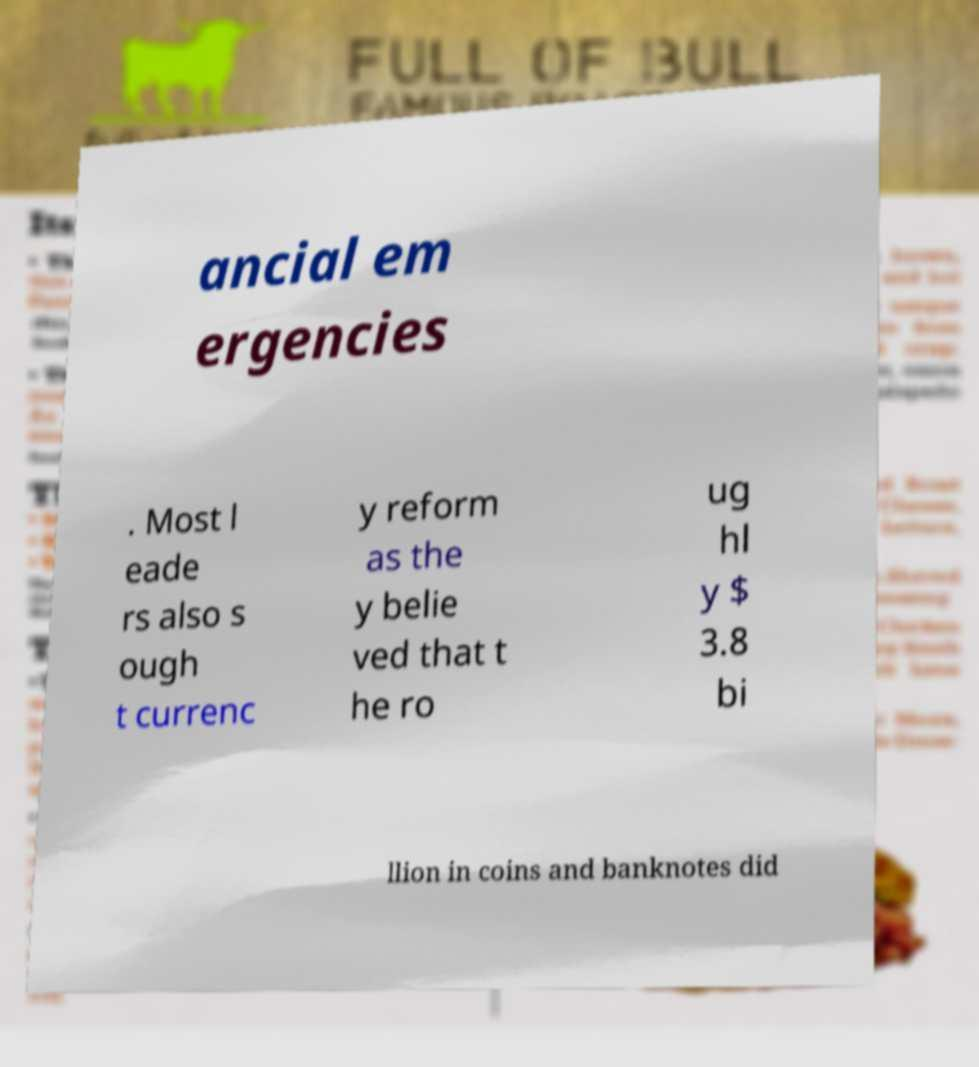Could you extract and type out the text from this image? ancial em ergencies . Most l eade rs also s ough t currenc y reform as the y belie ved that t he ro ug hl y $ 3.8 bi llion in coins and banknotes did 